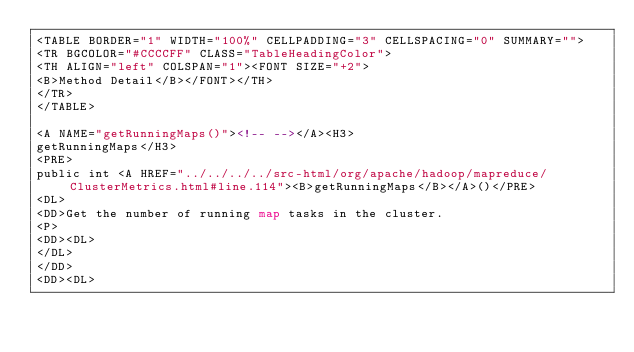<code> <loc_0><loc_0><loc_500><loc_500><_HTML_><TABLE BORDER="1" WIDTH="100%" CELLPADDING="3" CELLSPACING="0" SUMMARY="">
<TR BGCOLOR="#CCCCFF" CLASS="TableHeadingColor">
<TH ALIGN="left" COLSPAN="1"><FONT SIZE="+2">
<B>Method Detail</B></FONT></TH>
</TR>
</TABLE>

<A NAME="getRunningMaps()"><!-- --></A><H3>
getRunningMaps</H3>
<PRE>
public int <A HREF="../../../../src-html/org/apache/hadoop/mapreduce/ClusterMetrics.html#line.114"><B>getRunningMaps</B></A>()</PRE>
<DL>
<DD>Get the number of running map tasks in the cluster.
<P>
<DD><DL>
</DL>
</DD>
<DD><DL>
</code> 